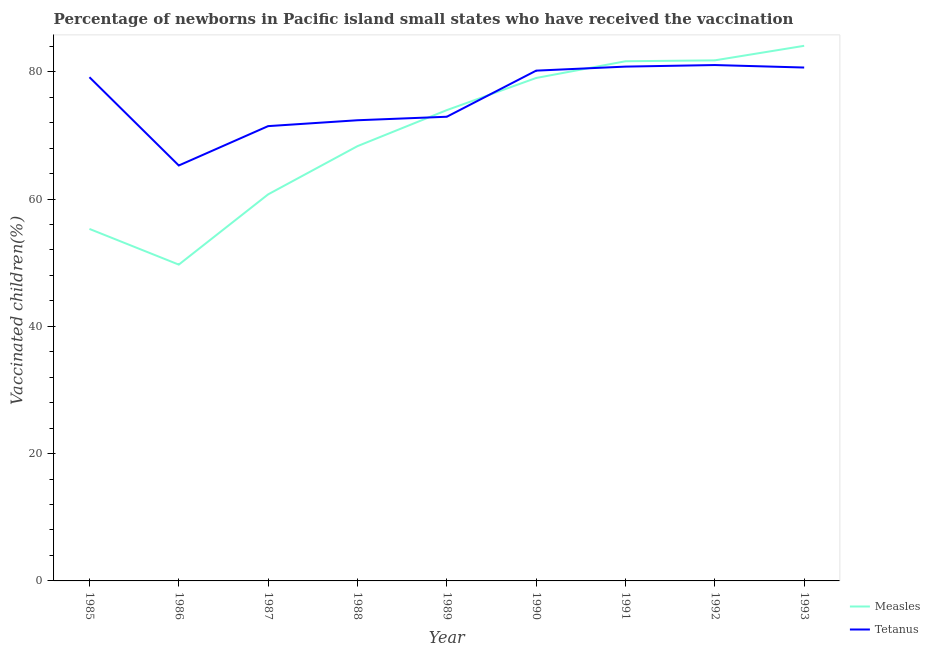Does the line corresponding to percentage of newborns who received vaccination for tetanus intersect with the line corresponding to percentage of newborns who received vaccination for measles?
Keep it short and to the point. Yes. What is the percentage of newborns who received vaccination for measles in 1988?
Offer a very short reply. 68.3. Across all years, what is the maximum percentage of newborns who received vaccination for measles?
Give a very brief answer. 84.07. Across all years, what is the minimum percentage of newborns who received vaccination for measles?
Provide a short and direct response. 49.69. In which year was the percentage of newborns who received vaccination for tetanus maximum?
Give a very brief answer. 1992. What is the total percentage of newborns who received vaccination for tetanus in the graph?
Your answer should be very brief. 683.8. What is the difference between the percentage of newborns who received vaccination for measles in 1987 and that in 1992?
Provide a short and direct response. -21.05. What is the difference between the percentage of newborns who received vaccination for tetanus in 1988 and the percentage of newborns who received vaccination for measles in 1987?
Offer a very short reply. 11.64. What is the average percentage of newborns who received vaccination for tetanus per year?
Give a very brief answer. 75.98. In the year 1986, what is the difference between the percentage of newborns who received vaccination for tetanus and percentage of newborns who received vaccination for measles?
Offer a terse response. 15.57. What is the ratio of the percentage of newborns who received vaccination for tetanus in 1989 to that in 1992?
Ensure brevity in your answer.  0.9. Is the difference between the percentage of newborns who received vaccination for tetanus in 1985 and 1990 greater than the difference between the percentage of newborns who received vaccination for measles in 1985 and 1990?
Offer a very short reply. Yes. What is the difference between the highest and the second highest percentage of newborns who received vaccination for tetanus?
Your response must be concise. 0.25. What is the difference between the highest and the lowest percentage of newborns who received vaccination for tetanus?
Ensure brevity in your answer.  15.78. In how many years, is the percentage of newborns who received vaccination for measles greater than the average percentage of newborns who received vaccination for measles taken over all years?
Your answer should be very brief. 5. Is the percentage of newborns who received vaccination for tetanus strictly less than the percentage of newborns who received vaccination for measles over the years?
Your response must be concise. No. How many years are there in the graph?
Your answer should be compact. 9. What is the difference between two consecutive major ticks on the Y-axis?
Give a very brief answer. 20. Does the graph contain grids?
Make the answer very short. No. Where does the legend appear in the graph?
Give a very brief answer. Bottom right. How many legend labels are there?
Your answer should be compact. 2. What is the title of the graph?
Keep it short and to the point. Percentage of newborns in Pacific island small states who have received the vaccination. Does "Revenue" appear as one of the legend labels in the graph?
Make the answer very short. No. What is the label or title of the X-axis?
Offer a terse response. Year. What is the label or title of the Y-axis?
Your answer should be very brief. Vaccinated children(%)
. What is the Vaccinated children(%)
 in Measles in 1985?
Give a very brief answer. 55.3. What is the Vaccinated children(%)
 of Tetanus in 1985?
Your answer should be compact. 79.13. What is the Vaccinated children(%)
 of Measles in 1986?
Offer a terse response. 49.69. What is the Vaccinated children(%)
 of Tetanus in 1986?
Provide a short and direct response. 65.27. What is the Vaccinated children(%)
 of Measles in 1987?
Offer a very short reply. 60.73. What is the Vaccinated children(%)
 in Tetanus in 1987?
Give a very brief answer. 71.45. What is the Vaccinated children(%)
 of Measles in 1988?
Provide a succinct answer. 68.3. What is the Vaccinated children(%)
 of Tetanus in 1988?
Keep it short and to the point. 72.37. What is the Vaccinated children(%)
 of Measles in 1989?
Ensure brevity in your answer.  73.96. What is the Vaccinated children(%)
 of Tetanus in 1989?
Keep it short and to the point. 72.92. What is the Vaccinated children(%)
 of Measles in 1990?
Your answer should be compact. 79.01. What is the Vaccinated children(%)
 of Tetanus in 1990?
Offer a terse response. 80.16. What is the Vaccinated children(%)
 of Measles in 1991?
Make the answer very short. 81.64. What is the Vaccinated children(%)
 in Tetanus in 1991?
Your answer should be compact. 80.8. What is the Vaccinated children(%)
 of Measles in 1992?
Your answer should be very brief. 81.78. What is the Vaccinated children(%)
 of Tetanus in 1992?
Make the answer very short. 81.04. What is the Vaccinated children(%)
 in Measles in 1993?
Ensure brevity in your answer.  84.07. What is the Vaccinated children(%)
 of Tetanus in 1993?
Your answer should be very brief. 80.65. Across all years, what is the maximum Vaccinated children(%)
 of Measles?
Ensure brevity in your answer.  84.07. Across all years, what is the maximum Vaccinated children(%)
 of Tetanus?
Your response must be concise. 81.04. Across all years, what is the minimum Vaccinated children(%)
 of Measles?
Offer a very short reply. 49.69. Across all years, what is the minimum Vaccinated children(%)
 of Tetanus?
Keep it short and to the point. 65.27. What is the total Vaccinated children(%)
 of Measles in the graph?
Offer a very short reply. 634.49. What is the total Vaccinated children(%)
 of Tetanus in the graph?
Keep it short and to the point. 683.8. What is the difference between the Vaccinated children(%)
 in Measles in 1985 and that in 1986?
Provide a succinct answer. 5.61. What is the difference between the Vaccinated children(%)
 in Tetanus in 1985 and that in 1986?
Your answer should be compact. 13.87. What is the difference between the Vaccinated children(%)
 in Measles in 1985 and that in 1987?
Offer a very short reply. -5.43. What is the difference between the Vaccinated children(%)
 of Tetanus in 1985 and that in 1987?
Provide a succinct answer. 7.68. What is the difference between the Vaccinated children(%)
 in Measles in 1985 and that in 1988?
Give a very brief answer. -13. What is the difference between the Vaccinated children(%)
 of Tetanus in 1985 and that in 1988?
Make the answer very short. 6.76. What is the difference between the Vaccinated children(%)
 in Measles in 1985 and that in 1989?
Provide a succinct answer. -18.66. What is the difference between the Vaccinated children(%)
 of Tetanus in 1985 and that in 1989?
Your answer should be very brief. 6.21. What is the difference between the Vaccinated children(%)
 in Measles in 1985 and that in 1990?
Keep it short and to the point. -23.71. What is the difference between the Vaccinated children(%)
 in Tetanus in 1985 and that in 1990?
Give a very brief answer. -1.03. What is the difference between the Vaccinated children(%)
 in Measles in 1985 and that in 1991?
Keep it short and to the point. -26.34. What is the difference between the Vaccinated children(%)
 of Tetanus in 1985 and that in 1991?
Offer a terse response. -1.67. What is the difference between the Vaccinated children(%)
 of Measles in 1985 and that in 1992?
Keep it short and to the point. -26.48. What is the difference between the Vaccinated children(%)
 of Tetanus in 1985 and that in 1992?
Your answer should be compact. -1.91. What is the difference between the Vaccinated children(%)
 in Measles in 1985 and that in 1993?
Your response must be concise. -28.77. What is the difference between the Vaccinated children(%)
 in Tetanus in 1985 and that in 1993?
Your answer should be very brief. -1.52. What is the difference between the Vaccinated children(%)
 in Measles in 1986 and that in 1987?
Offer a very short reply. -11.04. What is the difference between the Vaccinated children(%)
 of Tetanus in 1986 and that in 1987?
Offer a terse response. -6.18. What is the difference between the Vaccinated children(%)
 in Measles in 1986 and that in 1988?
Your response must be concise. -18.61. What is the difference between the Vaccinated children(%)
 in Tetanus in 1986 and that in 1988?
Keep it short and to the point. -7.11. What is the difference between the Vaccinated children(%)
 of Measles in 1986 and that in 1989?
Make the answer very short. -24.27. What is the difference between the Vaccinated children(%)
 in Tetanus in 1986 and that in 1989?
Provide a short and direct response. -7.66. What is the difference between the Vaccinated children(%)
 in Measles in 1986 and that in 1990?
Make the answer very short. -29.32. What is the difference between the Vaccinated children(%)
 of Tetanus in 1986 and that in 1990?
Your answer should be very brief. -14.9. What is the difference between the Vaccinated children(%)
 in Measles in 1986 and that in 1991?
Provide a succinct answer. -31.95. What is the difference between the Vaccinated children(%)
 in Tetanus in 1986 and that in 1991?
Your answer should be compact. -15.53. What is the difference between the Vaccinated children(%)
 in Measles in 1986 and that in 1992?
Give a very brief answer. -32.09. What is the difference between the Vaccinated children(%)
 of Tetanus in 1986 and that in 1992?
Your response must be concise. -15.78. What is the difference between the Vaccinated children(%)
 in Measles in 1986 and that in 1993?
Make the answer very short. -34.37. What is the difference between the Vaccinated children(%)
 of Tetanus in 1986 and that in 1993?
Keep it short and to the point. -15.39. What is the difference between the Vaccinated children(%)
 of Measles in 1987 and that in 1988?
Provide a short and direct response. -7.58. What is the difference between the Vaccinated children(%)
 of Tetanus in 1987 and that in 1988?
Keep it short and to the point. -0.92. What is the difference between the Vaccinated children(%)
 of Measles in 1987 and that in 1989?
Offer a very short reply. -13.24. What is the difference between the Vaccinated children(%)
 of Tetanus in 1987 and that in 1989?
Offer a terse response. -1.47. What is the difference between the Vaccinated children(%)
 in Measles in 1987 and that in 1990?
Provide a short and direct response. -18.28. What is the difference between the Vaccinated children(%)
 of Tetanus in 1987 and that in 1990?
Ensure brevity in your answer.  -8.72. What is the difference between the Vaccinated children(%)
 of Measles in 1987 and that in 1991?
Give a very brief answer. -20.91. What is the difference between the Vaccinated children(%)
 in Tetanus in 1987 and that in 1991?
Offer a terse response. -9.35. What is the difference between the Vaccinated children(%)
 in Measles in 1987 and that in 1992?
Your answer should be very brief. -21.05. What is the difference between the Vaccinated children(%)
 of Tetanus in 1987 and that in 1992?
Make the answer very short. -9.6. What is the difference between the Vaccinated children(%)
 in Measles in 1987 and that in 1993?
Provide a succinct answer. -23.34. What is the difference between the Vaccinated children(%)
 of Tetanus in 1987 and that in 1993?
Provide a succinct answer. -9.21. What is the difference between the Vaccinated children(%)
 of Measles in 1988 and that in 1989?
Make the answer very short. -5.66. What is the difference between the Vaccinated children(%)
 of Tetanus in 1988 and that in 1989?
Your answer should be compact. -0.55. What is the difference between the Vaccinated children(%)
 in Measles in 1988 and that in 1990?
Offer a very short reply. -10.71. What is the difference between the Vaccinated children(%)
 in Tetanus in 1988 and that in 1990?
Provide a succinct answer. -7.79. What is the difference between the Vaccinated children(%)
 of Measles in 1988 and that in 1991?
Offer a terse response. -13.34. What is the difference between the Vaccinated children(%)
 in Tetanus in 1988 and that in 1991?
Give a very brief answer. -8.43. What is the difference between the Vaccinated children(%)
 of Measles in 1988 and that in 1992?
Provide a succinct answer. -13.48. What is the difference between the Vaccinated children(%)
 in Tetanus in 1988 and that in 1992?
Ensure brevity in your answer.  -8.67. What is the difference between the Vaccinated children(%)
 of Measles in 1988 and that in 1993?
Your response must be concise. -15.76. What is the difference between the Vaccinated children(%)
 in Tetanus in 1988 and that in 1993?
Offer a very short reply. -8.28. What is the difference between the Vaccinated children(%)
 of Measles in 1989 and that in 1990?
Provide a succinct answer. -5.05. What is the difference between the Vaccinated children(%)
 in Tetanus in 1989 and that in 1990?
Give a very brief answer. -7.24. What is the difference between the Vaccinated children(%)
 in Measles in 1989 and that in 1991?
Your answer should be compact. -7.68. What is the difference between the Vaccinated children(%)
 of Tetanus in 1989 and that in 1991?
Provide a short and direct response. -7.88. What is the difference between the Vaccinated children(%)
 in Measles in 1989 and that in 1992?
Provide a succinct answer. -7.82. What is the difference between the Vaccinated children(%)
 of Tetanus in 1989 and that in 1992?
Your answer should be very brief. -8.12. What is the difference between the Vaccinated children(%)
 in Measles in 1989 and that in 1993?
Ensure brevity in your answer.  -10.1. What is the difference between the Vaccinated children(%)
 of Tetanus in 1989 and that in 1993?
Your answer should be very brief. -7.73. What is the difference between the Vaccinated children(%)
 of Measles in 1990 and that in 1991?
Ensure brevity in your answer.  -2.63. What is the difference between the Vaccinated children(%)
 of Tetanus in 1990 and that in 1991?
Provide a succinct answer. -0.63. What is the difference between the Vaccinated children(%)
 in Measles in 1990 and that in 1992?
Make the answer very short. -2.77. What is the difference between the Vaccinated children(%)
 in Tetanus in 1990 and that in 1992?
Keep it short and to the point. -0.88. What is the difference between the Vaccinated children(%)
 in Measles in 1990 and that in 1993?
Your answer should be very brief. -5.05. What is the difference between the Vaccinated children(%)
 of Tetanus in 1990 and that in 1993?
Provide a succinct answer. -0.49. What is the difference between the Vaccinated children(%)
 of Measles in 1991 and that in 1992?
Your response must be concise. -0.14. What is the difference between the Vaccinated children(%)
 in Tetanus in 1991 and that in 1992?
Keep it short and to the point. -0.25. What is the difference between the Vaccinated children(%)
 in Measles in 1991 and that in 1993?
Offer a terse response. -2.42. What is the difference between the Vaccinated children(%)
 in Tetanus in 1991 and that in 1993?
Provide a short and direct response. 0.14. What is the difference between the Vaccinated children(%)
 of Measles in 1992 and that in 1993?
Make the answer very short. -2.28. What is the difference between the Vaccinated children(%)
 in Tetanus in 1992 and that in 1993?
Give a very brief answer. 0.39. What is the difference between the Vaccinated children(%)
 of Measles in 1985 and the Vaccinated children(%)
 of Tetanus in 1986?
Your answer should be compact. -9.97. What is the difference between the Vaccinated children(%)
 of Measles in 1985 and the Vaccinated children(%)
 of Tetanus in 1987?
Offer a terse response. -16.15. What is the difference between the Vaccinated children(%)
 of Measles in 1985 and the Vaccinated children(%)
 of Tetanus in 1988?
Your response must be concise. -17.07. What is the difference between the Vaccinated children(%)
 of Measles in 1985 and the Vaccinated children(%)
 of Tetanus in 1989?
Give a very brief answer. -17.62. What is the difference between the Vaccinated children(%)
 of Measles in 1985 and the Vaccinated children(%)
 of Tetanus in 1990?
Offer a very short reply. -24.87. What is the difference between the Vaccinated children(%)
 of Measles in 1985 and the Vaccinated children(%)
 of Tetanus in 1991?
Offer a very short reply. -25.5. What is the difference between the Vaccinated children(%)
 in Measles in 1985 and the Vaccinated children(%)
 in Tetanus in 1992?
Your response must be concise. -25.75. What is the difference between the Vaccinated children(%)
 in Measles in 1985 and the Vaccinated children(%)
 in Tetanus in 1993?
Offer a terse response. -25.36. What is the difference between the Vaccinated children(%)
 in Measles in 1986 and the Vaccinated children(%)
 in Tetanus in 1987?
Ensure brevity in your answer.  -21.76. What is the difference between the Vaccinated children(%)
 of Measles in 1986 and the Vaccinated children(%)
 of Tetanus in 1988?
Provide a succinct answer. -22.68. What is the difference between the Vaccinated children(%)
 of Measles in 1986 and the Vaccinated children(%)
 of Tetanus in 1989?
Provide a succinct answer. -23.23. What is the difference between the Vaccinated children(%)
 of Measles in 1986 and the Vaccinated children(%)
 of Tetanus in 1990?
Provide a succinct answer. -30.47. What is the difference between the Vaccinated children(%)
 of Measles in 1986 and the Vaccinated children(%)
 of Tetanus in 1991?
Provide a short and direct response. -31.11. What is the difference between the Vaccinated children(%)
 in Measles in 1986 and the Vaccinated children(%)
 in Tetanus in 1992?
Your answer should be very brief. -31.35. What is the difference between the Vaccinated children(%)
 in Measles in 1986 and the Vaccinated children(%)
 in Tetanus in 1993?
Provide a succinct answer. -30.96. What is the difference between the Vaccinated children(%)
 of Measles in 1987 and the Vaccinated children(%)
 of Tetanus in 1988?
Ensure brevity in your answer.  -11.64. What is the difference between the Vaccinated children(%)
 of Measles in 1987 and the Vaccinated children(%)
 of Tetanus in 1989?
Your response must be concise. -12.19. What is the difference between the Vaccinated children(%)
 in Measles in 1987 and the Vaccinated children(%)
 in Tetanus in 1990?
Make the answer very short. -19.44. What is the difference between the Vaccinated children(%)
 of Measles in 1987 and the Vaccinated children(%)
 of Tetanus in 1991?
Your answer should be very brief. -20.07. What is the difference between the Vaccinated children(%)
 in Measles in 1987 and the Vaccinated children(%)
 in Tetanus in 1992?
Make the answer very short. -20.32. What is the difference between the Vaccinated children(%)
 in Measles in 1987 and the Vaccinated children(%)
 in Tetanus in 1993?
Ensure brevity in your answer.  -19.93. What is the difference between the Vaccinated children(%)
 in Measles in 1988 and the Vaccinated children(%)
 in Tetanus in 1989?
Provide a short and direct response. -4.62. What is the difference between the Vaccinated children(%)
 in Measles in 1988 and the Vaccinated children(%)
 in Tetanus in 1990?
Give a very brief answer. -11.86. What is the difference between the Vaccinated children(%)
 of Measles in 1988 and the Vaccinated children(%)
 of Tetanus in 1991?
Offer a very short reply. -12.5. What is the difference between the Vaccinated children(%)
 in Measles in 1988 and the Vaccinated children(%)
 in Tetanus in 1992?
Make the answer very short. -12.74. What is the difference between the Vaccinated children(%)
 in Measles in 1988 and the Vaccinated children(%)
 in Tetanus in 1993?
Provide a succinct answer. -12.35. What is the difference between the Vaccinated children(%)
 of Measles in 1989 and the Vaccinated children(%)
 of Tetanus in 1990?
Give a very brief answer. -6.2. What is the difference between the Vaccinated children(%)
 in Measles in 1989 and the Vaccinated children(%)
 in Tetanus in 1991?
Your answer should be very brief. -6.84. What is the difference between the Vaccinated children(%)
 in Measles in 1989 and the Vaccinated children(%)
 in Tetanus in 1992?
Your answer should be very brief. -7.08. What is the difference between the Vaccinated children(%)
 in Measles in 1989 and the Vaccinated children(%)
 in Tetanus in 1993?
Offer a very short reply. -6.69. What is the difference between the Vaccinated children(%)
 of Measles in 1990 and the Vaccinated children(%)
 of Tetanus in 1991?
Provide a short and direct response. -1.79. What is the difference between the Vaccinated children(%)
 of Measles in 1990 and the Vaccinated children(%)
 of Tetanus in 1992?
Ensure brevity in your answer.  -2.03. What is the difference between the Vaccinated children(%)
 of Measles in 1990 and the Vaccinated children(%)
 of Tetanus in 1993?
Offer a very short reply. -1.64. What is the difference between the Vaccinated children(%)
 of Measles in 1991 and the Vaccinated children(%)
 of Tetanus in 1992?
Your response must be concise. 0.6. What is the difference between the Vaccinated children(%)
 in Measles in 1991 and the Vaccinated children(%)
 in Tetanus in 1993?
Your response must be concise. 0.99. What is the difference between the Vaccinated children(%)
 in Measles in 1992 and the Vaccinated children(%)
 in Tetanus in 1993?
Provide a short and direct response. 1.13. What is the average Vaccinated children(%)
 in Measles per year?
Give a very brief answer. 70.5. What is the average Vaccinated children(%)
 of Tetanus per year?
Your answer should be very brief. 75.98. In the year 1985, what is the difference between the Vaccinated children(%)
 in Measles and Vaccinated children(%)
 in Tetanus?
Make the answer very short. -23.83. In the year 1986, what is the difference between the Vaccinated children(%)
 in Measles and Vaccinated children(%)
 in Tetanus?
Provide a succinct answer. -15.57. In the year 1987, what is the difference between the Vaccinated children(%)
 of Measles and Vaccinated children(%)
 of Tetanus?
Keep it short and to the point. -10.72. In the year 1988, what is the difference between the Vaccinated children(%)
 of Measles and Vaccinated children(%)
 of Tetanus?
Give a very brief answer. -4.07. In the year 1989, what is the difference between the Vaccinated children(%)
 in Measles and Vaccinated children(%)
 in Tetanus?
Make the answer very short. 1.04. In the year 1990, what is the difference between the Vaccinated children(%)
 of Measles and Vaccinated children(%)
 of Tetanus?
Your answer should be very brief. -1.15. In the year 1991, what is the difference between the Vaccinated children(%)
 of Measles and Vaccinated children(%)
 of Tetanus?
Offer a very short reply. 0.84. In the year 1992, what is the difference between the Vaccinated children(%)
 in Measles and Vaccinated children(%)
 in Tetanus?
Ensure brevity in your answer.  0.74. In the year 1993, what is the difference between the Vaccinated children(%)
 of Measles and Vaccinated children(%)
 of Tetanus?
Ensure brevity in your answer.  3.41. What is the ratio of the Vaccinated children(%)
 of Measles in 1985 to that in 1986?
Offer a very short reply. 1.11. What is the ratio of the Vaccinated children(%)
 in Tetanus in 1985 to that in 1986?
Give a very brief answer. 1.21. What is the ratio of the Vaccinated children(%)
 in Measles in 1985 to that in 1987?
Offer a terse response. 0.91. What is the ratio of the Vaccinated children(%)
 in Tetanus in 1985 to that in 1987?
Your answer should be compact. 1.11. What is the ratio of the Vaccinated children(%)
 in Measles in 1985 to that in 1988?
Your answer should be very brief. 0.81. What is the ratio of the Vaccinated children(%)
 of Tetanus in 1985 to that in 1988?
Offer a very short reply. 1.09. What is the ratio of the Vaccinated children(%)
 of Measles in 1985 to that in 1989?
Ensure brevity in your answer.  0.75. What is the ratio of the Vaccinated children(%)
 of Tetanus in 1985 to that in 1989?
Your answer should be very brief. 1.09. What is the ratio of the Vaccinated children(%)
 of Measles in 1985 to that in 1990?
Offer a terse response. 0.7. What is the ratio of the Vaccinated children(%)
 of Tetanus in 1985 to that in 1990?
Your answer should be compact. 0.99. What is the ratio of the Vaccinated children(%)
 in Measles in 1985 to that in 1991?
Provide a short and direct response. 0.68. What is the ratio of the Vaccinated children(%)
 in Tetanus in 1985 to that in 1991?
Your answer should be compact. 0.98. What is the ratio of the Vaccinated children(%)
 in Measles in 1985 to that in 1992?
Make the answer very short. 0.68. What is the ratio of the Vaccinated children(%)
 of Tetanus in 1985 to that in 1992?
Provide a short and direct response. 0.98. What is the ratio of the Vaccinated children(%)
 in Measles in 1985 to that in 1993?
Offer a very short reply. 0.66. What is the ratio of the Vaccinated children(%)
 of Tetanus in 1985 to that in 1993?
Offer a terse response. 0.98. What is the ratio of the Vaccinated children(%)
 of Measles in 1986 to that in 1987?
Provide a succinct answer. 0.82. What is the ratio of the Vaccinated children(%)
 in Tetanus in 1986 to that in 1987?
Your answer should be very brief. 0.91. What is the ratio of the Vaccinated children(%)
 in Measles in 1986 to that in 1988?
Provide a succinct answer. 0.73. What is the ratio of the Vaccinated children(%)
 in Tetanus in 1986 to that in 1988?
Offer a very short reply. 0.9. What is the ratio of the Vaccinated children(%)
 in Measles in 1986 to that in 1989?
Provide a succinct answer. 0.67. What is the ratio of the Vaccinated children(%)
 in Tetanus in 1986 to that in 1989?
Your answer should be compact. 0.9. What is the ratio of the Vaccinated children(%)
 in Measles in 1986 to that in 1990?
Your response must be concise. 0.63. What is the ratio of the Vaccinated children(%)
 of Tetanus in 1986 to that in 1990?
Your answer should be compact. 0.81. What is the ratio of the Vaccinated children(%)
 in Measles in 1986 to that in 1991?
Give a very brief answer. 0.61. What is the ratio of the Vaccinated children(%)
 of Tetanus in 1986 to that in 1991?
Make the answer very short. 0.81. What is the ratio of the Vaccinated children(%)
 of Measles in 1986 to that in 1992?
Your response must be concise. 0.61. What is the ratio of the Vaccinated children(%)
 of Tetanus in 1986 to that in 1992?
Give a very brief answer. 0.81. What is the ratio of the Vaccinated children(%)
 of Measles in 1986 to that in 1993?
Ensure brevity in your answer.  0.59. What is the ratio of the Vaccinated children(%)
 of Tetanus in 1986 to that in 1993?
Ensure brevity in your answer.  0.81. What is the ratio of the Vaccinated children(%)
 of Measles in 1987 to that in 1988?
Keep it short and to the point. 0.89. What is the ratio of the Vaccinated children(%)
 in Tetanus in 1987 to that in 1988?
Provide a succinct answer. 0.99. What is the ratio of the Vaccinated children(%)
 in Measles in 1987 to that in 1989?
Offer a terse response. 0.82. What is the ratio of the Vaccinated children(%)
 in Tetanus in 1987 to that in 1989?
Your response must be concise. 0.98. What is the ratio of the Vaccinated children(%)
 of Measles in 1987 to that in 1990?
Your answer should be very brief. 0.77. What is the ratio of the Vaccinated children(%)
 in Tetanus in 1987 to that in 1990?
Keep it short and to the point. 0.89. What is the ratio of the Vaccinated children(%)
 in Measles in 1987 to that in 1991?
Your answer should be very brief. 0.74. What is the ratio of the Vaccinated children(%)
 in Tetanus in 1987 to that in 1991?
Give a very brief answer. 0.88. What is the ratio of the Vaccinated children(%)
 of Measles in 1987 to that in 1992?
Offer a very short reply. 0.74. What is the ratio of the Vaccinated children(%)
 in Tetanus in 1987 to that in 1992?
Your response must be concise. 0.88. What is the ratio of the Vaccinated children(%)
 of Measles in 1987 to that in 1993?
Your answer should be very brief. 0.72. What is the ratio of the Vaccinated children(%)
 in Tetanus in 1987 to that in 1993?
Keep it short and to the point. 0.89. What is the ratio of the Vaccinated children(%)
 in Measles in 1988 to that in 1989?
Your answer should be compact. 0.92. What is the ratio of the Vaccinated children(%)
 in Tetanus in 1988 to that in 1989?
Keep it short and to the point. 0.99. What is the ratio of the Vaccinated children(%)
 in Measles in 1988 to that in 1990?
Your answer should be compact. 0.86. What is the ratio of the Vaccinated children(%)
 of Tetanus in 1988 to that in 1990?
Keep it short and to the point. 0.9. What is the ratio of the Vaccinated children(%)
 of Measles in 1988 to that in 1991?
Keep it short and to the point. 0.84. What is the ratio of the Vaccinated children(%)
 in Tetanus in 1988 to that in 1991?
Ensure brevity in your answer.  0.9. What is the ratio of the Vaccinated children(%)
 in Measles in 1988 to that in 1992?
Offer a very short reply. 0.84. What is the ratio of the Vaccinated children(%)
 of Tetanus in 1988 to that in 1992?
Provide a short and direct response. 0.89. What is the ratio of the Vaccinated children(%)
 in Measles in 1988 to that in 1993?
Make the answer very short. 0.81. What is the ratio of the Vaccinated children(%)
 in Tetanus in 1988 to that in 1993?
Your answer should be very brief. 0.9. What is the ratio of the Vaccinated children(%)
 of Measles in 1989 to that in 1990?
Provide a succinct answer. 0.94. What is the ratio of the Vaccinated children(%)
 in Tetanus in 1989 to that in 1990?
Your answer should be very brief. 0.91. What is the ratio of the Vaccinated children(%)
 of Measles in 1989 to that in 1991?
Offer a terse response. 0.91. What is the ratio of the Vaccinated children(%)
 of Tetanus in 1989 to that in 1991?
Offer a very short reply. 0.9. What is the ratio of the Vaccinated children(%)
 of Measles in 1989 to that in 1992?
Offer a terse response. 0.9. What is the ratio of the Vaccinated children(%)
 in Tetanus in 1989 to that in 1992?
Offer a very short reply. 0.9. What is the ratio of the Vaccinated children(%)
 of Measles in 1989 to that in 1993?
Offer a terse response. 0.88. What is the ratio of the Vaccinated children(%)
 in Tetanus in 1989 to that in 1993?
Your answer should be compact. 0.9. What is the ratio of the Vaccinated children(%)
 in Measles in 1990 to that in 1991?
Keep it short and to the point. 0.97. What is the ratio of the Vaccinated children(%)
 in Tetanus in 1990 to that in 1991?
Make the answer very short. 0.99. What is the ratio of the Vaccinated children(%)
 of Measles in 1990 to that in 1992?
Offer a very short reply. 0.97. What is the ratio of the Vaccinated children(%)
 of Tetanus in 1990 to that in 1992?
Provide a succinct answer. 0.99. What is the ratio of the Vaccinated children(%)
 of Measles in 1990 to that in 1993?
Ensure brevity in your answer.  0.94. What is the ratio of the Vaccinated children(%)
 of Tetanus in 1990 to that in 1993?
Your response must be concise. 0.99. What is the ratio of the Vaccinated children(%)
 in Measles in 1991 to that in 1993?
Your answer should be compact. 0.97. What is the ratio of the Vaccinated children(%)
 in Tetanus in 1991 to that in 1993?
Provide a short and direct response. 1. What is the ratio of the Vaccinated children(%)
 in Measles in 1992 to that in 1993?
Offer a terse response. 0.97. What is the difference between the highest and the second highest Vaccinated children(%)
 of Measles?
Offer a very short reply. 2.28. What is the difference between the highest and the second highest Vaccinated children(%)
 in Tetanus?
Ensure brevity in your answer.  0.25. What is the difference between the highest and the lowest Vaccinated children(%)
 in Measles?
Give a very brief answer. 34.37. What is the difference between the highest and the lowest Vaccinated children(%)
 of Tetanus?
Keep it short and to the point. 15.78. 